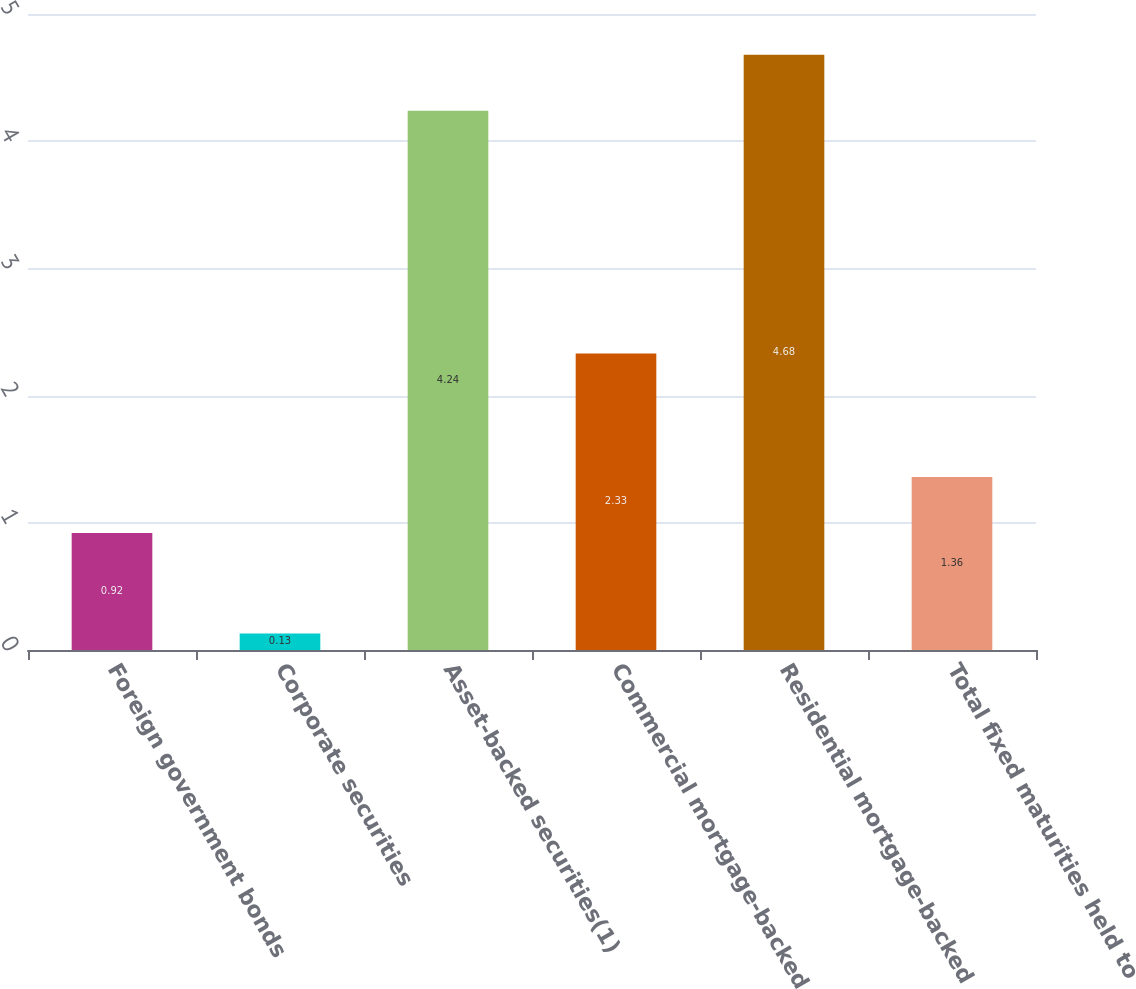Convert chart to OTSL. <chart><loc_0><loc_0><loc_500><loc_500><bar_chart><fcel>Foreign government bonds<fcel>Corporate securities<fcel>Asset-backed securities(1)<fcel>Commercial mortgage-backed<fcel>Residential mortgage-backed<fcel>Total fixed maturities held to<nl><fcel>0.92<fcel>0.13<fcel>4.24<fcel>2.33<fcel>4.68<fcel>1.36<nl></chart> 